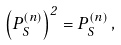Convert formula to latex. <formula><loc_0><loc_0><loc_500><loc_500>\left ( P _ { S } ^ { ( n ) } \right ) ^ { 2 } = P _ { S } ^ { ( n ) } \, ,</formula> 